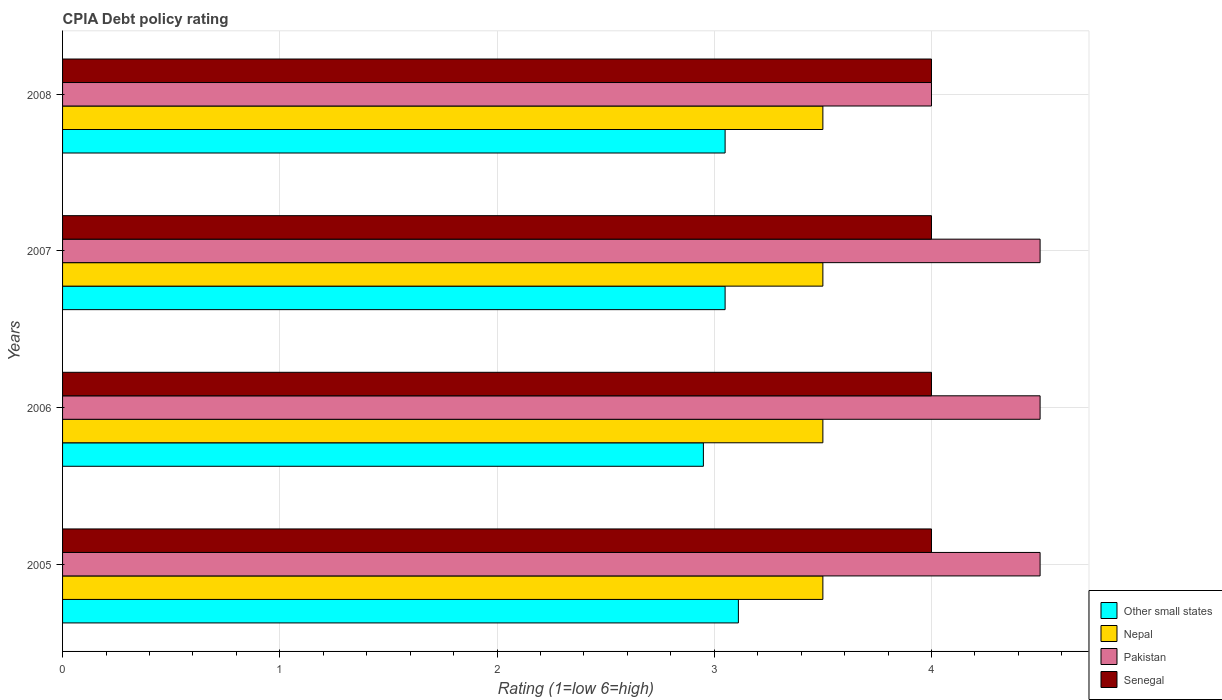How many different coloured bars are there?
Your response must be concise. 4. How many groups of bars are there?
Your response must be concise. 4. Are the number of bars per tick equal to the number of legend labels?
Make the answer very short. Yes. How many bars are there on the 3rd tick from the bottom?
Ensure brevity in your answer.  4. What is the label of the 1st group of bars from the top?
Provide a succinct answer. 2008. What is the CPIA rating in Other small states in 2008?
Your response must be concise. 3.05. Across all years, what is the minimum CPIA rating in Other small states?
Provide a short and direct response. 2.95. In which year was the CPIA rating in Pakistan maximum?
Your answer should be compact. 2005. What is the difference between the CPIA rating in Senegal in 2008 and the CPIA rating in Other small states in 2007?
Give a very brief answer. 0.95. What is the average CPIA rating in Nepal per year?
Offer a terse response. 3.5. In the year 2005, what is the difference between the CPIA rating in Other small states and CPIA rating in Senegal?
Give a very brief answer. -0.89. Is the difference between the CPIA rating in Other small states in 2005 and 2007 greater than the difference between the CPIA rating in Senegal in 2005 and 2007?
Your response must be concise. Yes. In how many years, is the CPIA rating in Senegal greater than the average CPIA rating in Senegal taken over all years?
Ensure brevity in your answer.  0. Is it the case that in every year, the sum of the CPIA rating in Senegal and CPIA rating in Pakistan is greater than the sum of CPIA rating in Nepal and CPIA rating in Other small states?
Your answer should be very brief. No. What does the 3rd bar from the top in 2008 represents?
Your response must be concise. Nepal. What does the 2nd bar from the bottom in 2006 represents?
Your answer should be very brief. Nepal. Does the graph contain grids?
Give a very brief answer. Yes. What is the title of the graph?
Keep it short and to the point. CPIA Debt policy rating. Does "Hong Kong" appear as one of the legend labels in the graph?
Keep it short and to the point. No. What is the label or title of the Y-axis?
Give a very brief answer. Years. What is the Rating (1=low 6=high) of Other small states in 2005?
Offer a terse response. 3.11. What is the Rating (1=low 6=high) of Senegal in 2005?
Offer a very short reply. 4. What is the Rating (1=low 6=high) in Other small states in 2006?
Keep it short and to the point. 2.95. What is the Rating (1=low 6=high) of Senegal in 2006?
Ensure brevity in your answer.  4. What is the Rating (1=low 6=high) of Other small states in 2007?
Offer a terse response. 3.05. What is the Rating (1=low 6=high) of Senegal in 2007?
Your answer should be very brief. 4. What is the Rating (1=low 6=high) of Other small states in 2008?
Give a very brief answer. 3.05. What is the Rating (1=low 6=high) in Pakistan in 2008?
Your answer should be very brief. 4. Across all years, what is the maximum Rating (1=low 6=high) of Other small states?
Offer a very short reply. 3.11. Across all years, what is the maximum Rating (1=low 6=high) in Nepal?
Offer a very short reply. 3.5. Across all years, what is the maximum Rating (1=low 6=high) in Pakistan?
Offer a terse response. 4.5. Across all years, what is the maximum Rating (1=low 6=high) of Senegal?
Offer a very short reply. 4. Across all years, what is the minimum Rating (1=low 6=high) of Other small states?
Offer a terse response. 2.95. Across all years, what is the minimum Rating (1=low 6=high) of Senegal?
Give a very brief answer. 4. What is the total Rating (1=low 6=high) in Other small states in the graph?
Give a very brief answer. 12.16. What is the total Rating (1=low 6=high) in Nepal in the graph?
Provide a short and direct response. 14. What is the total Rating (1=low 6=high) of Senegal in the graph?
Make the answer very short. 16. What is the difference between the Rating (1=low 6=high) in Other small states in 2005 and that in 2006?
Your answer should be compact. 0.16. What is the difference between the Rating (1=low 6=high) of Pakistan in 2005 and that in 2006?
Provide a succinct answer. 0. What is the difference between the Rating (1=low 6=high) of Senegal in 2005 and that in 2006?
Your answer should be compact. 0. What is the difference between the Rating (1=low 6=high) of Other small states in 2005 and that in 2007?
Provide a short and direct response. 0.06. What is the difference between the Rating (1=low 6=high) in Nepal in 2005 and that in 2007?
Offer a very short reply. 0. What is the difference between the Rating (1=low 6=high) in Pakistan in 2005 and that in 2007?
Your answer should be very brief. 0. What is the difference between the Rating (1=low 6=high) of Other small states in 2005 and that in 2008?
Keep it short and to the point. 0.06. What is the difference between the Rating (1=low 6=high) in Nepal in 2005 and that in 2008?
Ensure brevity in your answer.  0. What is the difference between the Rating (1=low 6=high) in Pakistan in 2005 and that in 2008?
Offer a terse response. 0.5. What is the difference between the Rating (1=low 6=high) of Senegal in 2005 and that in 2008?
Your answer should be very brief. 0. What is the difference between the Rating (1=low 6=high) in Nepal in 2006 and that in 2007?
Keep it short and to the point. 0. What is the difference between the Rating (1=low 6=high) in Senegal in 2006 and that in 2007?
Make the answer very short. 0. What is the difference between the Rating (1=low 6=high) in Nepal in 2006 and that in 2008?
Offer a terse response. 0. What is the difference between the Rating (1=low 6=high) of Pakistan in 2006 and that in 2008?
Offer a very short reply. 0.5. What is the difference between the Rating (1=low 6=high) of Pakistan in 2007 and that in 2008?
Offer a very short reply. 0.5. What is the difference between the Rating (1=low 6=high) of Other small states in 2005 and the Rating (1=low 6=high) of Nepal in 2006?
Your answer should be compact. -0.39. What is the difference between the Rating (1=low 6=high) in Other small states in 2005 and the Rating (1=low 6=high) in Pakistan in 2006?
Offer a very short reply. -1.39. What is the difference between the Rating (1=low 6=high) of Other small states in 2005 and the Rating (1=low 6=high) of Senegal in 2006?
Ensure brevity in your answer.  -0.89. What is the difference between the Rating (1=low 6=high) of Nepal in 2005 and the Rating (1=low 6=high) of Pakistan in 2006?
Make the answer very short. -1. What is the difference between the Rating (1=low 6=high) in Other small states in 2005 and the Rating (1=low 6=high) in Nepal in 2007?
Provide a short and direct response. -0.39. What is the difference between the Rating (1=low 6=high) in Other small states in 2005 and the Rating (1=low 6=high) in Pakistan in 2007?
Provide a short and direct response. -1.39. What is the difference between the Rating (1=low 6=high) of Other small states in 2005 and the Rating (1=low 6=high) of Senegal in 2007?
Provide a short and direct response. -0.89. What is the difference between the Rating (1=low 6=high) in Pakistan in 2005 and the Rating (1=low 6=high) in Senegal in 2007?
Offer a terse response. 0.5. What is the difference between the Rating (1=low 6=high) in Other small states in 2005 and the Rating (1=low 6=high) in Nepal in 2008?
Ensure brevity in your answer.  -0.39. What is the difference between the Rating (1=low 6=high) in Other small states in 2005 and the Rating (1=low 6=high) in Pakistan in 2008?
Make the answer very short. -0.89. What is the difference between the Rating (1=low 6=high) in Other small states in 2005 and the Rating (1=low 6=high) in Senegal in 2008?
Your answer should be compact. -0.89. What is the difference between the Rating (1=low 6=high) of Nepal in 2005 and the Rating (1=low 6=high) of Senegal in 2008?
Make the answer very short. -0.5. What is the difference between the Rating (1=low 6=high) of Other small states in 2006 and the Rating (1=low 6=high) of Nepal in 2007?
Your answer should be compact. -0.55. What is the difference between the Rating (1=low 6=high) in Other small states in 2006 and the Rating (1=low 6=high) in Pakistan in 2007?
Your response must be concise. -1.55. What is the difference between the Rating (1=low 6=high) in Other small states in 2006 and the Rating (1=low 6=high) in Senegal in 2007?
Give a very brief answer. -1.05. What is the difference between the Rating (1=low 6=high) of Nepal in 2006 and the Rating (1=low 6=high) of Pakistan in 2007?
Offer a terse response. -1. What is the difference between the Rating (1=low 6=high) in Nepal in 2006 and the Rating (1=low 6=high) in Senegal in 2007?
Your response must be concise. -0.5. What is the difference between the Rating (1=low 6=high) of Pakistan in 2006 and the Rating (1=low 6=high) of Senegal in 2007?
Ensure brevity in your answer.  0.5. What is the difference between the Rating (1=low 6=high) of Other small states in 2006 and the Rating (1=low 6=high) of Nepal in 2008?
Offer a very short reply. -0.55. What is the difference between the Rating (1=low 6=high) in Other small states in 2006 and the Rating (1=low 6=high) in Pakistan in 2008?
Keep it short and to the point. -1.05. What is the difference between the Rating (1=low 6=high) of Other small states in 2006 and the Rating (1=low 6=high) of Senegal in 2008?
Your answer should be very brief. -1.05. What is the difference between the Rating (1=low 6=high) of Nepal in 2006 and the Rating (1=low 6=high) of Senegal in 2008?
Keep it short and to the point. -0.5. What is the difference between the Rating (1=low 6=high) in Pakistan in 2006 and the Rating (1=low 6=high) in Senegal in 2008?
Offer a very short reply. 0.5. What is the difference between the Rating (1=low 6=high) in Other small states in 2007 and the Rating (1=low 6=high) in Nepal in 2008?
Your answer should be very brief. -0.45. What is the difference between the Rating (1=low 6=high) in Other small states in 2007 and the Rating (1=low 6=high) in Pakistan in 2008?
Provide a succinct answer. -0.95. What is the difference between the Rating (1=low 6=high) in Other small states in 2007 and the Rating (1=low 6=high) in Senegal in 2008?
Your answer should be compact. -0.95. What is the difference between the Rating (1=low 6=high) of Nepal in 2007 and the Rating (1=low 6=high) of Senegal in 2008?
Give a very brief answer. -0.5. What is the difference between the Rating (1=low 6=high) in Pakistan in 2007 and the Rating (1=low 6=high) in Senegal in 2008?
Your response must be concise. 0.5. What is the average Rating (1=low 6=high) of Other small states per year?
Ensure brevity in your answer.  3.04. What is the average Rating (1=low 6=high) of Nepal per year?
Your answer should be compact. 3.5. What is the average Rating (1=low 6=high) of Pakistan per year?
Give a very brief answer. 4.38. What is the average Rating (1=low 6=high) of Senegal per year?
Give a very brief answer. 4. In the year 2005, what is the difference between the Rating (1=low 6=high) of Other small states and Rating (1=low 6=high) of Nepal?
Keep it short and to the point. -0.39. In the year 2005, what is the difference between the Rating (1=low 6=high) in Other small states and Rating (1=low 6=high) in Pakistan?
Your response must be concise. -1.39. In the year 2005, what is the difference between the Rating (1=low 6=high) of Other small states and Rating (1=low 6=high) of Senegal?
Give a very brief answer. -0.89. In the year 2005, what is the difference between the Rating (1=low 6=high) in Nepal and Rating (1=low 6=high) in Pakistan?
Provide a succinct answer. -1. In the year 2006, what is the difference between the Rating (1=low 6=high) of Other small states and Rating (1=low 6=high) of Nepal?
Provide a short and direct response. -0.55. In the year 2006, what is the difference between the Rating (1=low 6=high) in Other small states and Rating (1=low 6=high) in Pakistan?
Offer a terse response. -1.55. In the year 2006, what is the difference between the Rating (1=low 6=high) in Other small states and Rating (1=low 6=high) in Senegal?
Offer a very short reply. -1.05. In the year 2006, what is the difference between the Rating (1=low 6=high) in Pakistan and Rating (1=low 6=high) in Senegal?
Keep it short and to the point. 0.5. In the year 2007, what is the difference between the Rating (1=low 6=high) of Other small states and Rating (1=low 6=high) of Nepal?
Give a very brief answer. -0.45. In the year 2007, what is the difference between the Rating (1=low 6=high) in Other small states and Rating (1=low 6=high) in Pakistan?
Keep it short and to the point. -1.45. In the year 2007, what is the difference between the Rating (1=low 6=high) of Other small states and Rating (1=low 6=high) of Senegal?
Offer a terse response. -0.95. In the year 2008, what is the difference between the Rating (1=low 6=high) in Other small states and Rating (1=low 6=high) in Nepal?
Keep it short and to the point. -0.45. In the year 2008, what is the difference between the Rating (1=low 6=high) of Other small states and Rating (1=low 6=high) of Pakistan?
Your answer should be compact. -0.95. In the year 2008, what is the difference between the Rating (1=low 6=high) in Other small states and Rating (1=low 6=high) in Senegal?
Your answer should be compact. -0.95. In the year 2008, what is the difference between the Rating (1=low 6=high) in Nepal and Rating (1=low 6=high) in Pakistan?
Provide a succinct answer. -0.5. In the year 2008, what is the difference between the Rating (1=low 6=high) of Nepal and Rating (1=low 6=high) of Senegal?
Provide a succinct answer. -0.5. What is the ratio of the Rating (1=low 6=high) of Other small states in 2005 to that in 2006?
Offer a terse response. 1.05. What is the ratio of the Rating (1=low 6=high) of Nepal in 2005 to that in 2007?
Your answer should be very brief. 1. What is the ratio of the Rating (1=low 6=high) in Pakistan in 2005 to that in 2007?
Keep it short and to the point. 1. What is the ratio of the Rating (1=low 6=high) in Nepal in 2005 to that in 2008?
Provide a short and direct response. 1. What is the ratio of the Rating (1=low 6=high) of Senegal in 2005 to that in 2008?
Ensure brevity in your answer.  1. What is the ratio of the Rating (1=low 6=high) in Other small states in 2006 to that in 2007?
Your answer should be very brief. 0.97. What is the ratio of the Rating (1=low 6=high) in Pakistan in 2006 to that in 2007?
Ensure brevity in your answer.  1. What is the ratio of the Rating (1=low 6=high) in Other small states in 2006 to that in 2008?
Provide a succinct answer. 0.97. What is the ratio of the Rating (1=low 6=high) in Senegal in 2006 to that in 2008?
Give a very brief answer. 1. What is the ratio of the Rating (1=low 6=high) of Pakistan in 2007 to that in 2008?
Give a very brief answer. 1.12. What is the ratio of the Rating (1=low 6=high) of Senegal in 2007 to that in 2008?
Your response must be concise. 1. What is the difference between the highest and the second highest Rating (1=low 6=high) of Other small states?
Offer a terse response. 0.06. What is the difference between the highest and the second highest Rating (1=low 6=high) in Pakistan?
Your response must be concise. 0. What is the difference between the highest and the lowest Rating (1=low 6=high) of Other small states?
Give a very brief answer. 0.16. 